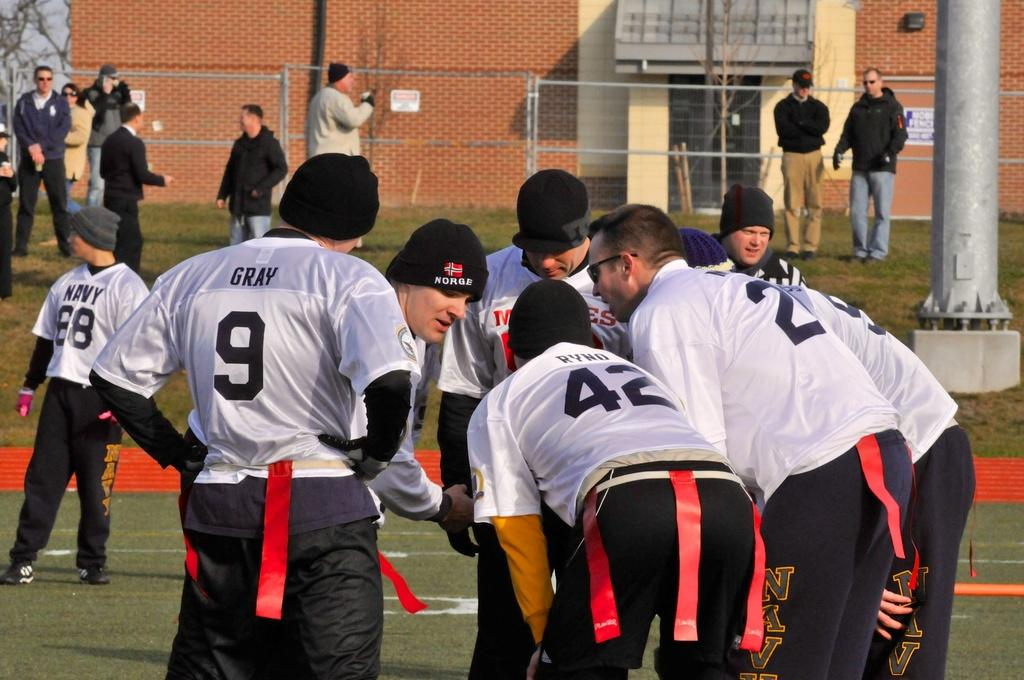<image>
Give a short and clear explanation of the subsequent image. Player number 9 stands in a huddle with other players. 